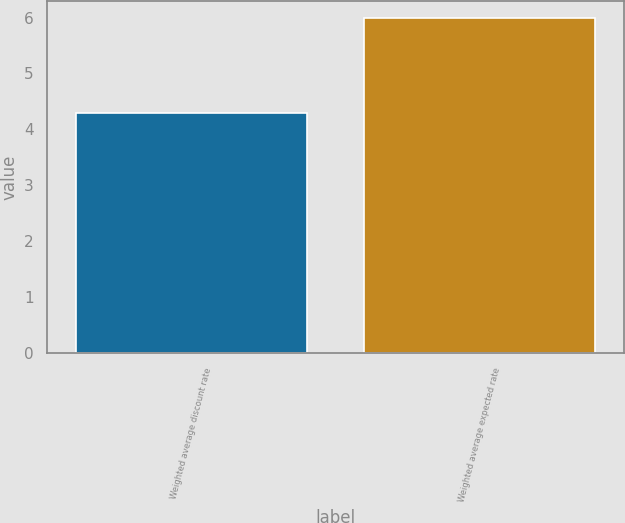Convert chart. <chart><loc_0><loc_0><loc_500><loc_500><bar_chart><fcel>Weighted average discount rate<fcel>Weighted average expected rate<nl><fcel>4.3<fcel>6<nl></chart> 